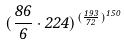<formula> <loc_0><loc_0><loc_500><loc_500>( \frac { 8 6 } { 6 } \cdot 2 2 4 ) ^ { ( \frac { 1 9 3 } { 7 2 } ) ^ { 1 5 0 } }</formula> 